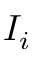<formula> <loc_0><loc_0><loc_500><loc_500>I _ { i }</formula> 